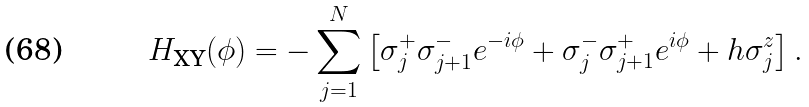Convert formula to latex. <formula><loc_0><loc_0><loc_500><loc_500>H _ { \text {XY} } ( \phi ) = - \sum _ { j = 1 } ^ { N } \left [ \sigma _ { j } ^ { + } \sigma _ { j + 1 } ^ { - } e ^ { - i \phi } + \sigma _ { j } ^ { - } \sigma _ { j + 1 } ^ { + } e ^ { i \phi } + h \sigma _ { j } ^ { z } \right ] .</formula> 